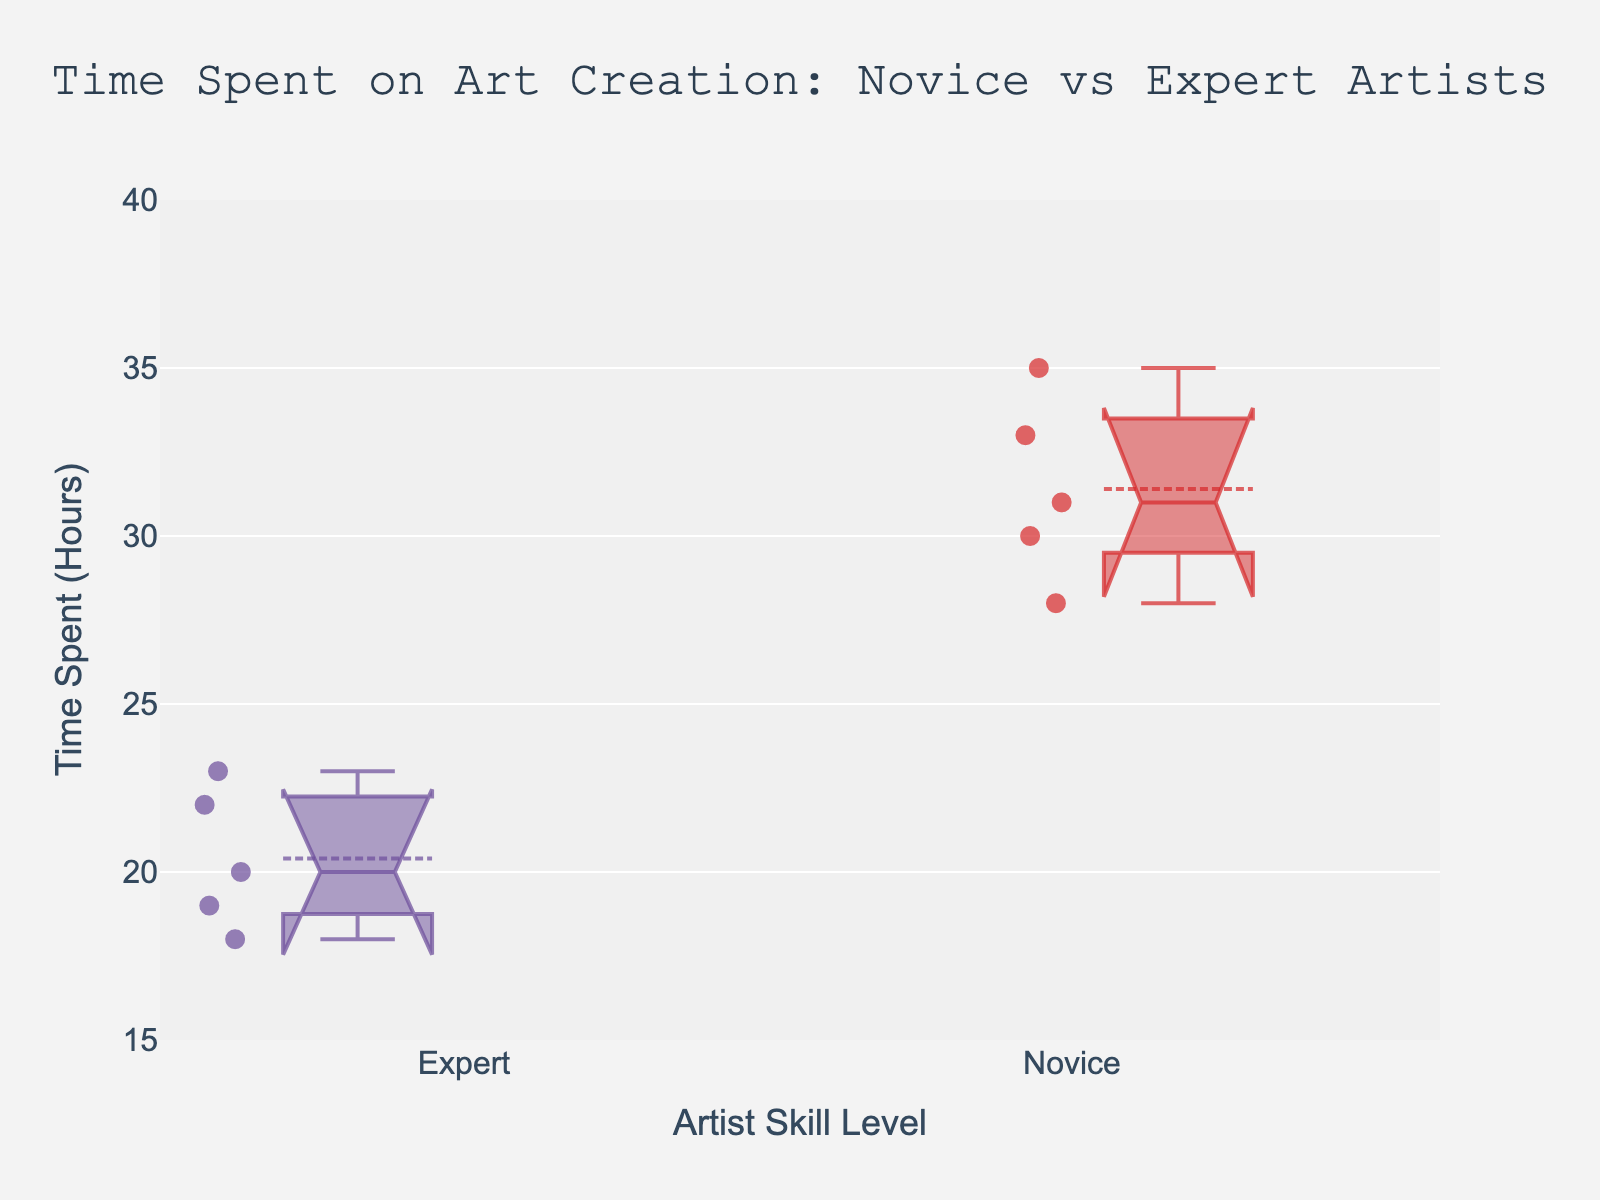what is the title of the figure? The title is displayed at the top of the figure. It provides a summary of what the plot represents. The title is "Time Spent on Art Creation: Novice vs Expert Artists."
Answer: Time Spent on Art Creation: Novice vs Expert Artists What does the y-axis represent? The y-axis label indicates what is being measured. The y-axis in this figure represents "Time Spent (Hours)."
Answer: Time Spent (Hours) Which group has a higher median time spent on art creation, novice or expert artists? The box plot shows the median as a line within the box. For novice artists, the median is higher compared to expert artists.
Answer: Novice artists What are the median time spent values for novice and expert artists? Observing the middle line of both notched boxes, the median for novice artists is around 31 hours and for expert artists is around 20 hours.
Answer: Novice: 31 hours, Expert: 20 hours How many novice artists were included in this study? The number of data points for novice artists can be counted by observing the individual points superimposed over the box plot. There are 5 points for novice artists.
Answer: 5 How many expert artists were included in this study? Similar to the previous question, the number of data points for expert artists can be counted, which is 5 points.
Answer: 5 What is the range of time spent on art creation by expert artists? The range can be determined by looking at the whiskers of the box plot for expert artists. It ranges from approximately 18 hours to 23 hours.
Answer: 18 to 23 hours Which group shows greater variability in time spent on art creation? Variability can be assessed by looking at the length of the boxes and the whiskers. The novice artists show greater variability as their box is taller and whiskers are longer.
Answer: Novice artists What are the lower and upper bounds of the notches for the novice artists' group? The notches represent the 95% confidence interval for the median. The lower bound is around 29 hours, and the upper bound is around 33 hours for novice artists.
Answer: 29 to 33 hours Are the confidence intervals for the medians of novice and expert artists overlapping? By observing the notches, the intervals for the two groups overlap slightly, indicating potential similarity in central tendency.
Answer: Yes 